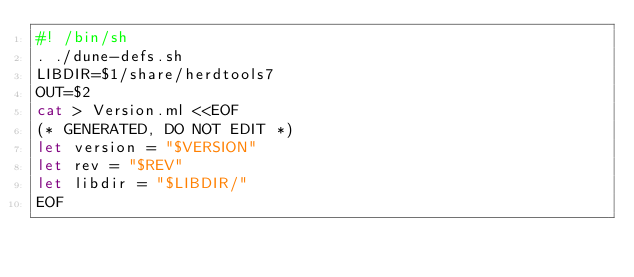<code> <loc_0><loc_0><loc_500><loc_500><_Bash_>#! /bin/sh
. ./dune-defs.sh
LIBDIR=$1/share/herdtools7
OUT=$2
cat > Version.ml <<EOF
(* GENERATED, DO NOT EDIT *)
let version = "$VERSION"
let rev = "$REV"
let libdir = "$LIBDIR/"
EOF
</code> 